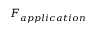<formula> <loc_0><loc_0><loc_500><loc_500>F _ { a p p l i c a t i o n }</formula> 